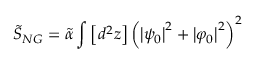<formula> <loc_0><loc_0><loc_500><loc_500>\widetilde { S } _ { N G } = \widetilde { \alpha } \int \left [ d ^ { 2 } z \right ] \left ( \left | \psi _ { 0 } \right | ^ { 2 } + \left | \varphi _ { 0 } \right | ^ { 2 } \right ) ^ { 2 }</formula> 